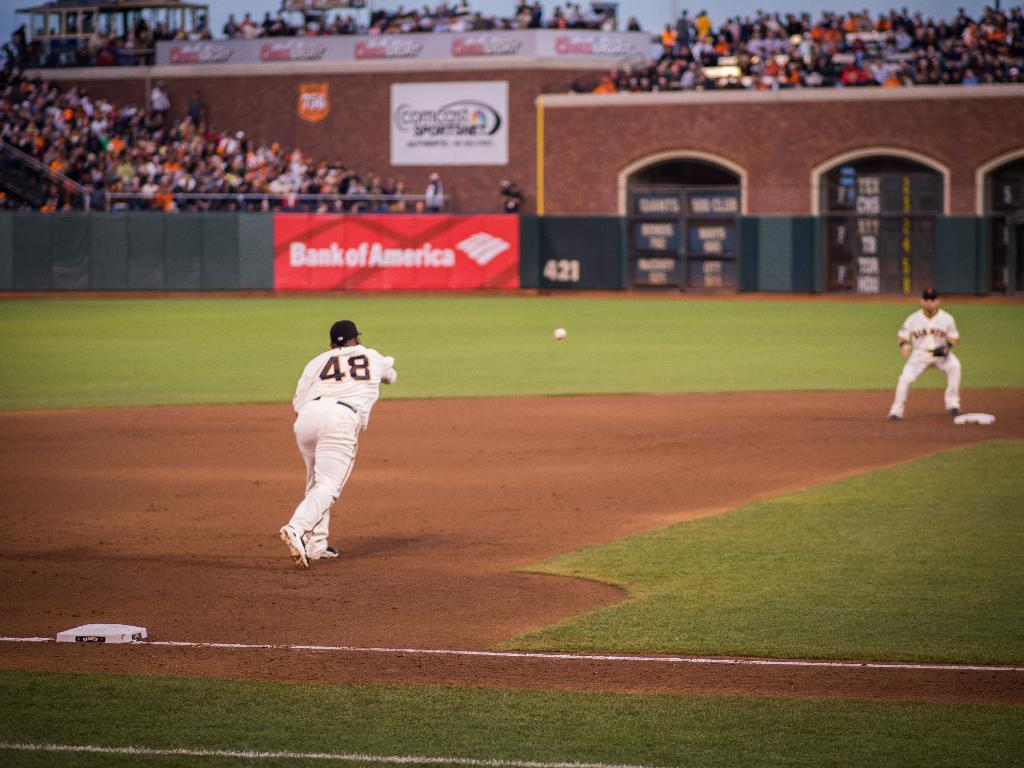<image>
Relay a brief, clear account of the picture shown. A third baseman throwing a ball to second base. The shirt says 48 on the back. 